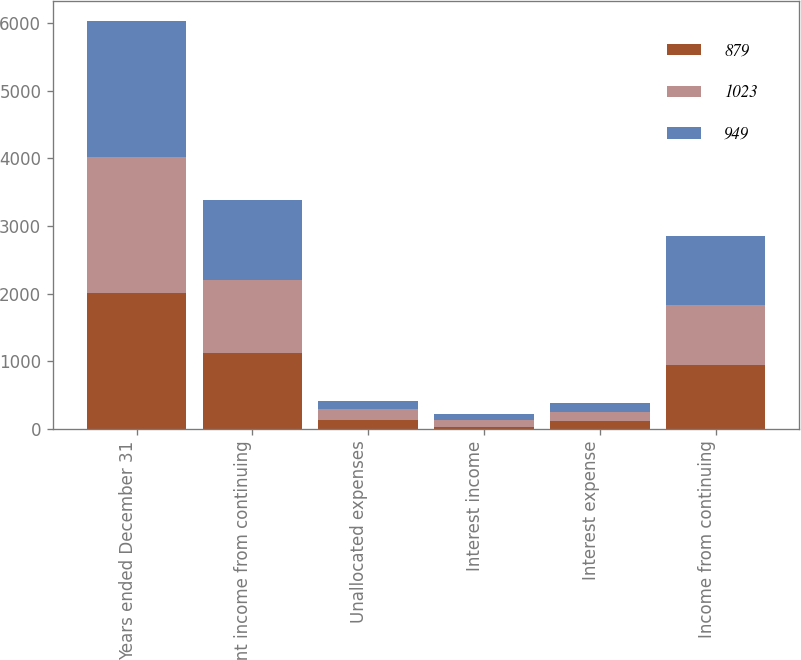<chart> <loc_0><loc_0><loc_500><loc_500><stacked_bar_chart><ecel><fcel>Years ended December 31<fcel>Segment income from continuing<fcel>Unallocated expenses<fcel>Interest income<fcel>Interest expense<fcel>Income from continuing<nl><fcel>879<fcel>2009<fcel>1119<fcel>127<fcel>30<fcel>122<fcel>949<nl><fcel>1023<fcel>2008<fcel>1076<fcel>165<fcel>94<fcel>126<fcel>879<nl><fcel>949<fcel>2007<fcel>1181<fcel>120<fcel>100<fcel>138<fcel>1023<nl></chart> 